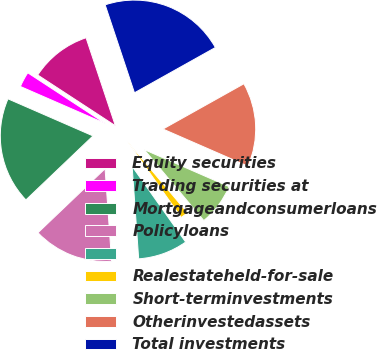<chart> <loc_0><loc_0><loc_500><loc_500><pie_chart><fcel>Equity securities<fcel>Trading securities at<fcel>Mortgageandconsumerloans<fcel>Policyloans<fcel>Unnamed: 4<fcel>Realestateheld-for-sale<fcel>Short-terminvestments<fcel>Otherinvestedassets<fcel>Total investments<nl><fcel>10.67%<fcel>2.67%<fcel>18.67%<fcel>14.0%<fcel>8.67%<fcel>1.33%<fcel>7.33%<fcel>14.67%<fcel>22.0%<nl></chart> 